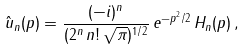<formula> <loc_0><loc_0><loc_500><loc_500>\hat { u } _ { n } ( p ) = \frac { ( - i ) ^ { n } } { ( 2 ^ { n } \, n ! \, \sqrt { \pi } ) ^ { 1 / 2 } } \, e ^ { - p ^ { 2 } / 2 } \, H _ { n } ( p ) \, ,</formula> 